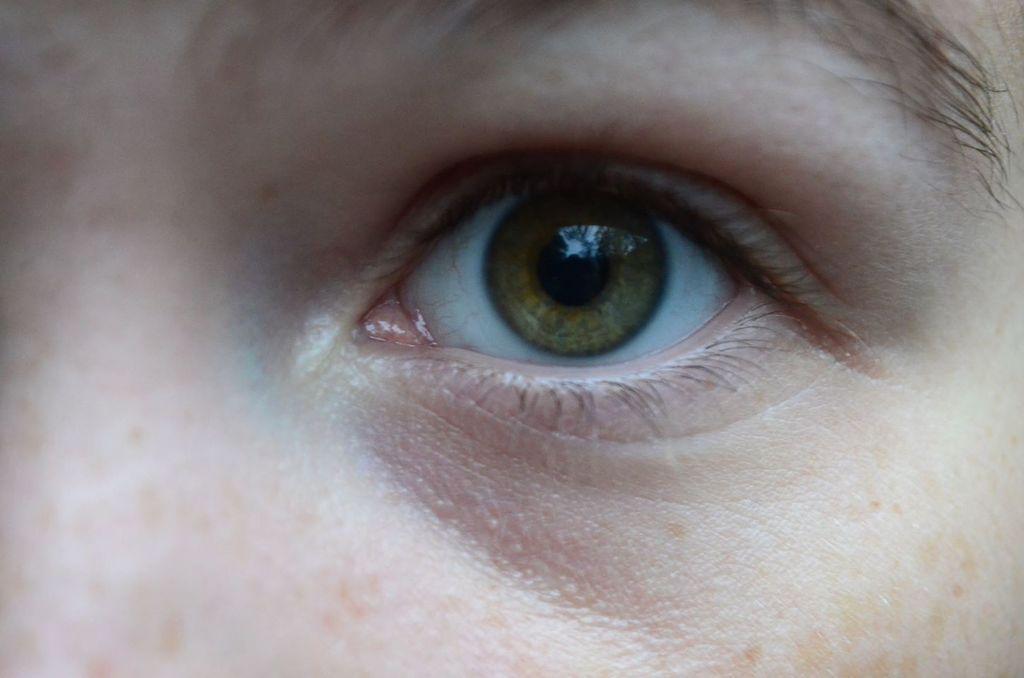Describe this image in one or two sentences. In this image, I can see a person's eye and an eyebrow. 